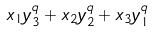Convert formula to latex. <formula><loc_0><loc_0><loc_500><loc_500>x _ { 1 } y _ { 3 } ^ { q } + x _ { 2 } y _ { 2 } ^ { q } + x _ { 3 } y _ { 1 } ^ { q }</formula> 